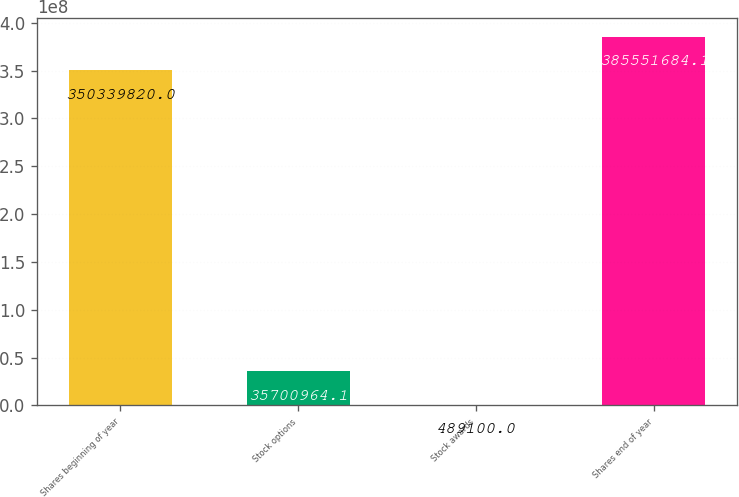<chart> <loc_0><loc_0><loc_500><loc_500><bar_chart><fcel>Shares beginning of year<fcel>Stock options<fcel>Stock awards<fcel>Shares end of year<nl><fcel>3.5034e+08<fcel>3.5701e+07<fcel>489100<fcel>3.85552e+08<nl></chart> 